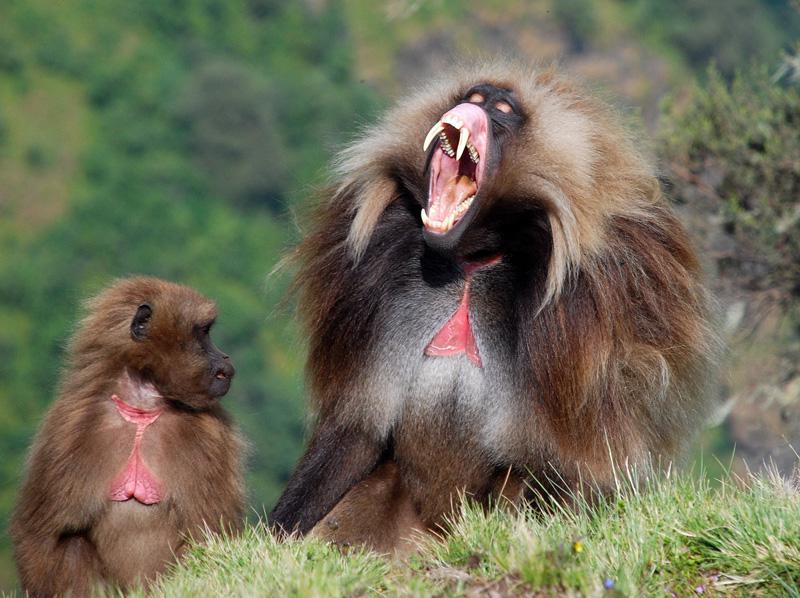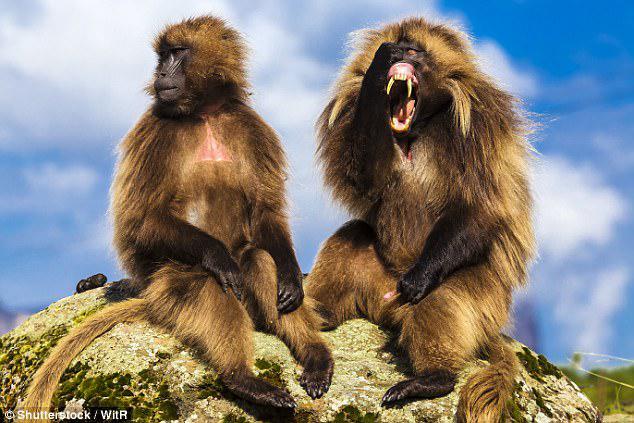The first image is the image on the left, the second image is the image on the right. Analyze the images presented: Is the assertion "At least one baboon has a wide open mouth." valid? Answer yes or no. Yes. The first image is the image on the left, the second image is the image on the right. Analyze the images presented: Is the assertion "in the right pic the primates fangs are fully shown" valid? Answer yes or no. Yes. 